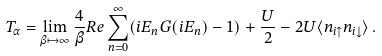<formula> <loc_0><loc_0><loc_500><loc_500>T _ { \alpha } = \lim _ { \beta \mapsto \infty } \frac { 4 } { \beta } R e \sum _ { n = 0 } ^ { \infty } ( i E _ { n } G ( i E _ { n } ) - 1 ) + \frac { U } { 2 } - 2 U \langle n _ { i \uparrow } n _ { i \downarrow } \rangle \, .</formula> 